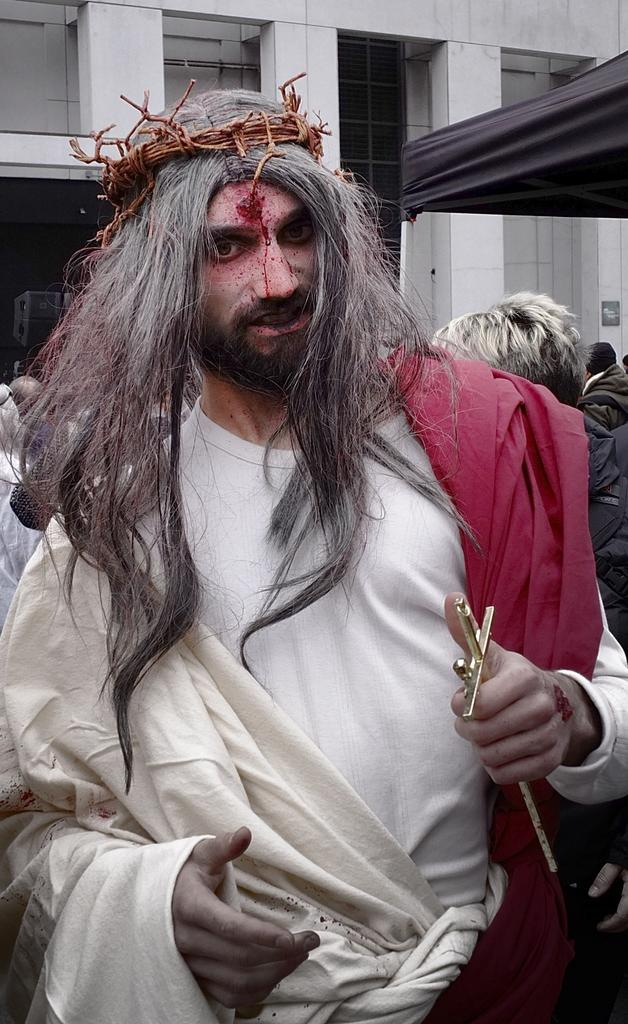What is the main subject of the image? There is a man standing in the center of the image. What is the man wearing? The man is wearing a costume. What is the man holding in his hand? The man is holding a cross in his hand. What can be seen in the background of the image? There are people and a building in the background of the image. What is the acoustics like in the building in the background of the image? The provided facts do not give any information about the acoustics of the building in the background. 